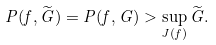Convert formula to latex. <formula><loc_0><loc_0><loc_500><loc_500>P ( f , \widetilde { G } ) = P ( f , G ) > \sup _ { J ( f ) } \widetilde { G } .</formula> 